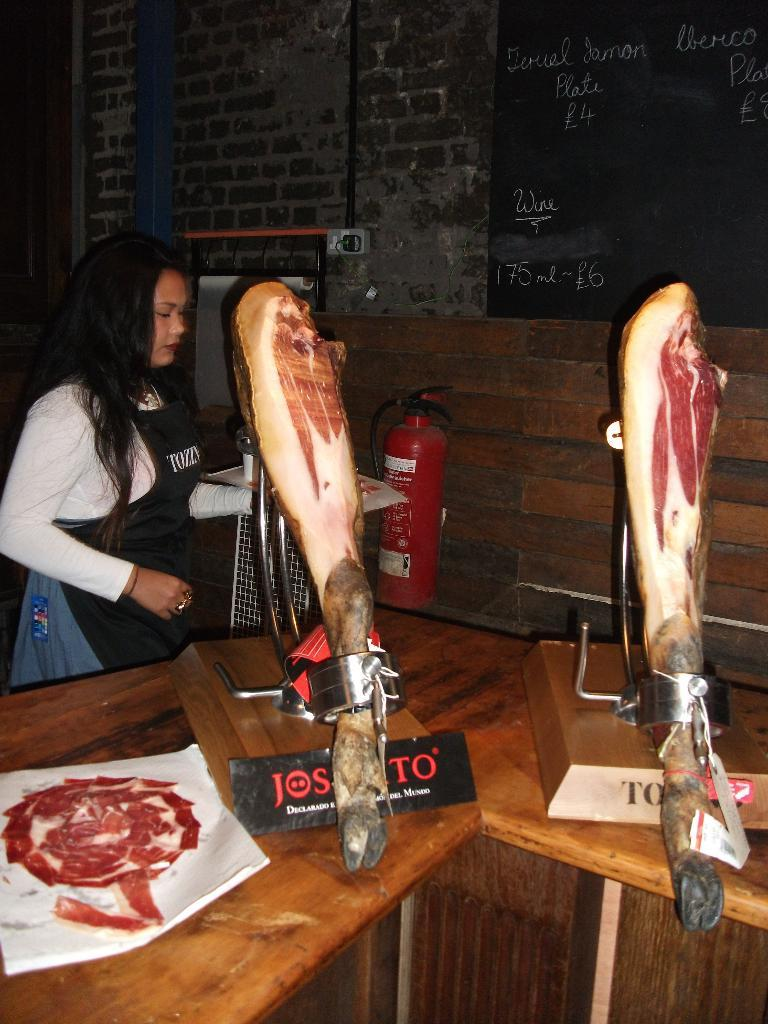Who is present in the image? There is a woman in the image. What is the woman doing in the image? The woman is standing in front of a table. What is on the table in the image? There is meat on the table. What can be seen in the background of the image? There is a fire extinguisher and a notice board in the background of the image. Is there a sofa in the image? No, there is no sofa present in the image. Can you describe the field visible in the image? There is no field visible in the image; it features a woman standing in front of a table with meat, a fire extinguisher, and a notice board in the background. 